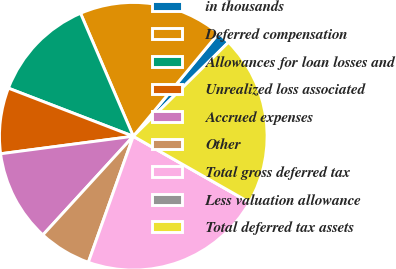Convert chart to OTSL. <chart><loc_0><loc_0><loc_500><loc_500><pie_chart><fcel>in thousands<fcel>Deferred compensation<fcel>Allowances for loan losses and<fcel>Unrealized loss associated<fcel>Accrued expenses<fcel>Other<fcel>Total gross deferred tax<fcel>Less valuation allowance<fcel>Total deferred tax assets<nl><fcel>1.59%<fcel>17.46%<fcel>12.7%<fcel>7.94%<fcel>11.11%<fcel>6.35%<fcel>22.22%<fcel>0.0%<fcel>20.63%<nl></chart> 